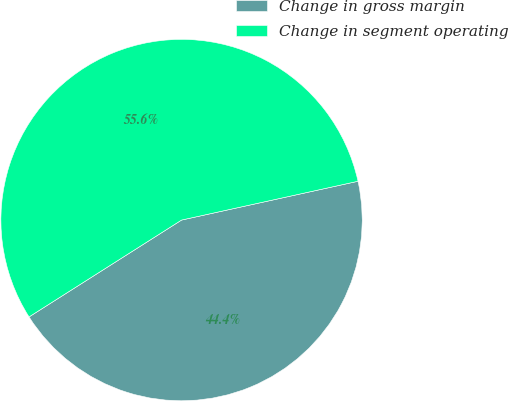<chart> <loc_0><loc_0><loc_500><loc_500><pie_chart><fcel>Change in gross margin<fcel>Change in segment operating<nl><fcel>44.44%<fcel>55.56%<nl></chart> 